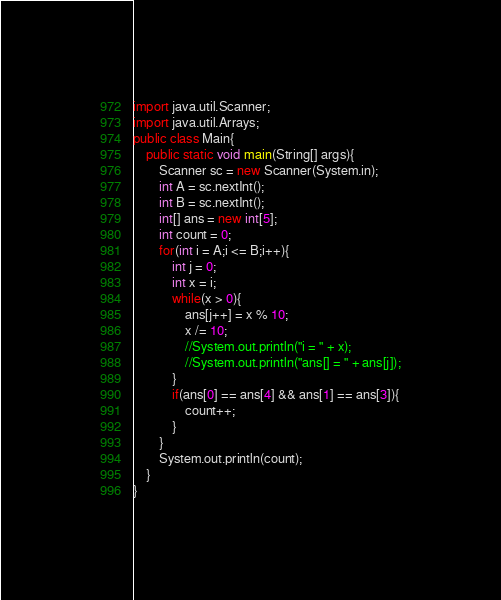<code> <loc_0><loc_0><loc_500><loc_500><_Java_>import java.util.Scanner;
import java.util.Arrays;
public class Main{
    public static void main(String[] args){
        Scanner sc = new Scanner(System.in);
        int A = sc.nextInt();
        int B = sc.nextInt();
        int[] ans = new int[5];
        int count = 0;
        for(int i = A;i <= B;i++){
            int j = 0;
            int x = i;
            while(x > 0){
                ans[j++] = x % 10;
                x /= 10;
                //System.out.println("i = " + x);
                //System.out.println("ans[] = " + ans[j]);
            }
            if(ans[0] == ans[4] && ans[1] == ans[3]){
                count++;
            }
        }
        System.out.println(count);
    }
}
</code> 